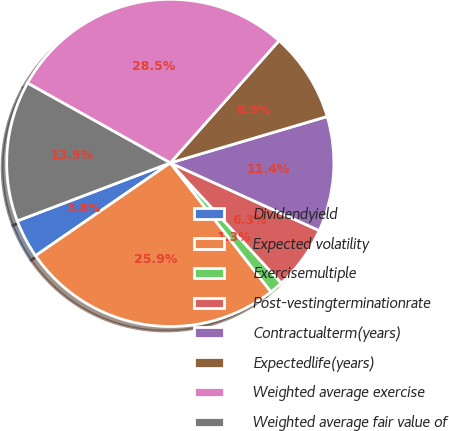<chart> <loc_0><loc_0><loc_500><loc_500><pie_chart><fcel>Dividendyield<fcel>Expected volatility<fcel>Exercisemultiple<fcel>Post-vestingterminationrate<fcel>Contractualterm(years)<fcel>Expectedlife(years)<fcel>Weighted average exercise<fcel>Weighted average fair value of<nl><fcel>3.83%<fcel>25.95%<fcel>1.32%<fcel>6.34%<fcel>11.37%<fcel>8.85%<fcel>28.46%<fcel>13.88%<nl></chart> 